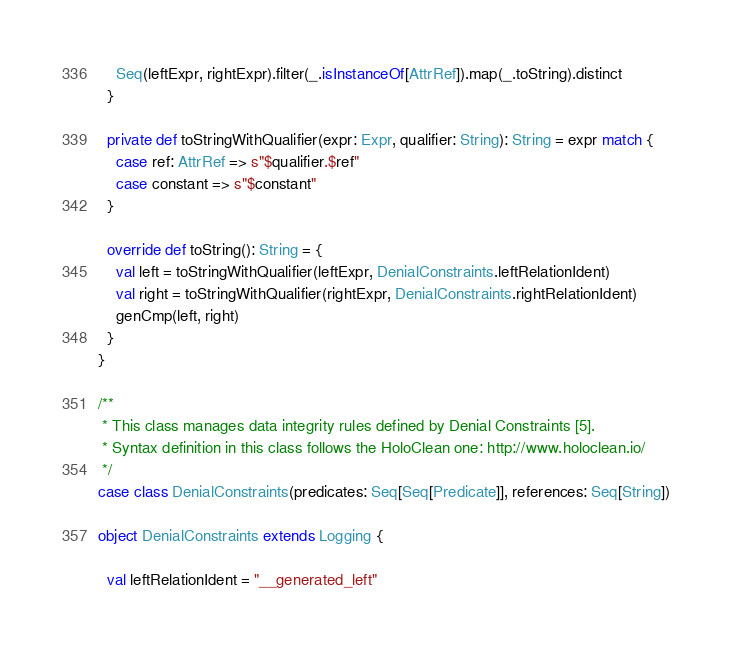Convert code to text. <code><loc_0><loc_0><loc_500><loc_500><_Scala_>    Seq(leftExpr, rightExpr).filter(_.isInstanceOf[AttrRef]).map(_.toString).distinct
  }

  private def toStringWithQualifier(expr: Expr, qualifier: String): String = expr match {
    case ref: AttrRef => s"$qualifier.$ref"
    case constant => s"$constant"
  }

  override def toString(): String = {
    val left = toStringWithQualifier(leftExpr, DenialConstraints.leftRelationIdent)
    val right = toStringWithQualifier(rightExpr, DenialConstraints.rightRelationIdent)
    genCmp(left, right)
  }
}

/**
 * This class manages data integrity rules defined by Denial Constraints [5].
 * Syntax definition in this class follows the HoloClean one: http://www.holoclean.io/
 */
case class DenialConstraints(predicates: Seq[Seq[Predicate]], references: Seq[String])

object DenialConstraints extends Logging {

  val leftRelationIdent = "__generated_left"</code> 